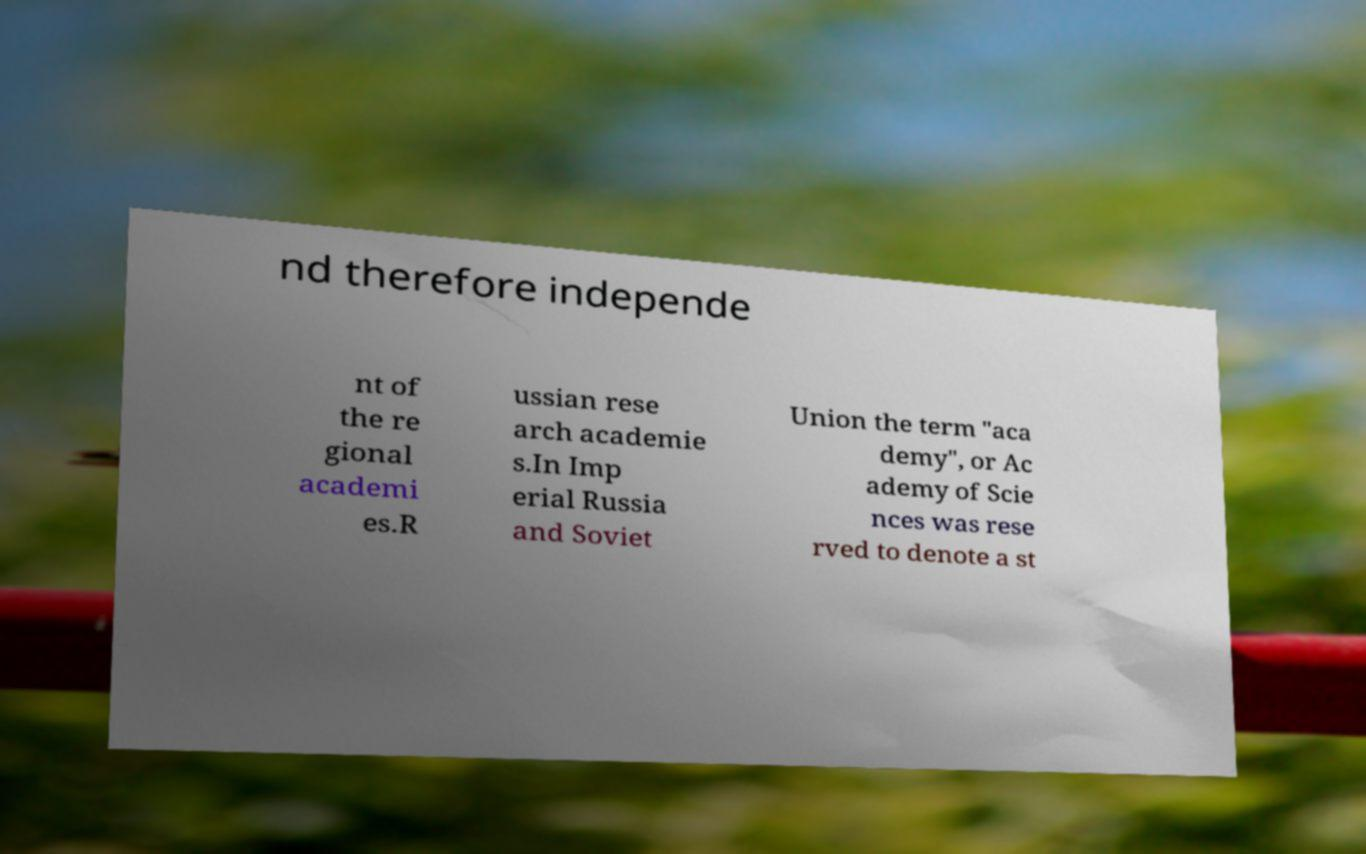There's text embedded in this image that I need extracted. Can you transcribe it verbatim? nd therefore independe nt of the re gional academi es.R ussian rese arch academie s.In Imp erial Russia and Soviet Union the term "aca demy", or Ac ademy of Scie nces was rese rved to denote a st 